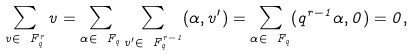Convert formula to latex. <formula><loc_0><loc_0><loc_500><loc_500>\sum _ { v \in \ F _ { q } ^ { r } } v = \sum _ { \alpha \in \ F _ { q } } \sum _ { v ^ { \prime } \in \ F _ { q } ^ { r - 1 } } ( \alpha , v ^ { \prime } ) = \sum _ { \alpha \in \ F _ { q } } ( q ^ { r - 1 } \alpha , 0 ) = 0 ,</formula> 